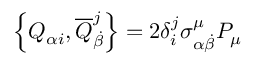Convert formula to latex. <formula><loc_0><loc_0><loc_500><loc_500>\left \{ Q _ { \alpha i } , { \overline { Q } } _ { \dot { \beta } } ^ { j } \right \} = 2 \delta _ { i } ^ { j } \sigma _ { \alpha { \dot { \beta } } } ^ { \mu } P _ { \mu }</formula> 